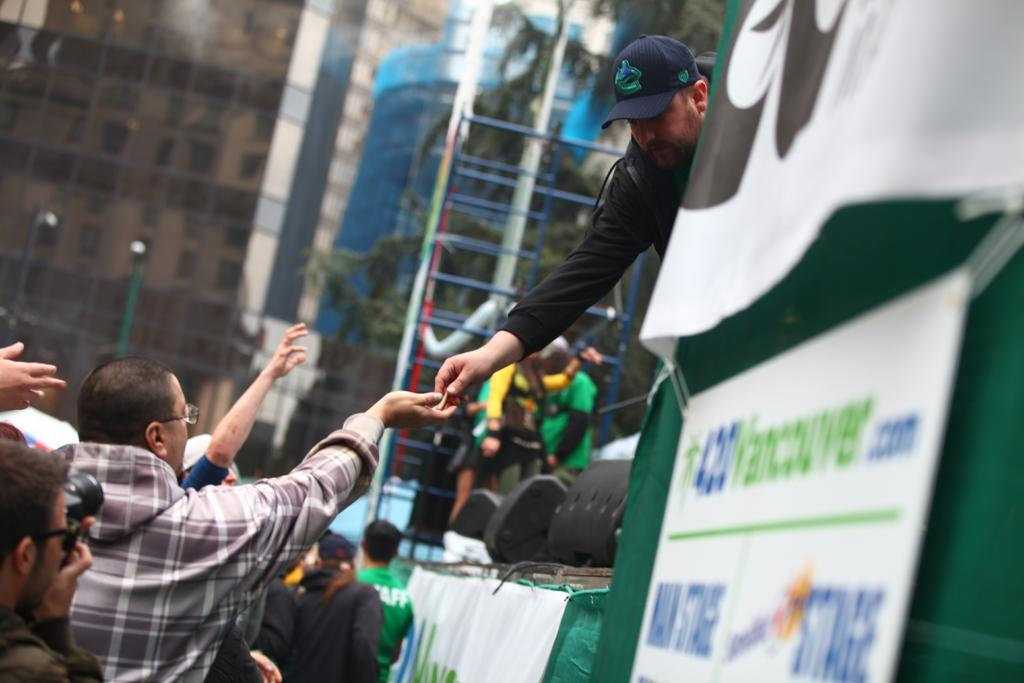What are the people in the image doing? There are people on the road, on a ladder, and on a stage in the image. Can you describe the activities of the people on the stage? There is a person on a stage, and there are black color objects on the stage in the image. What can be seen in the background of the image? There are buildings visible in the image, as well as a tree. What type of fuel is being used by the apple in the image? There is no apple present in the image, and therefore no fuel can be associated with it. 